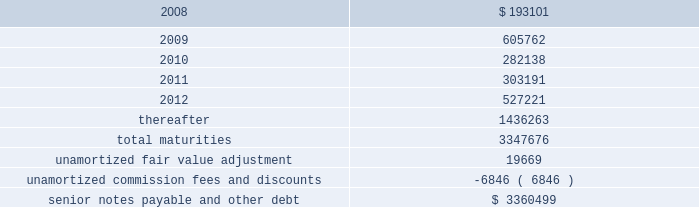Ventas , inc .
Notes to consolidated financial statements 2014 ( continued ) applicable indenture .
The issuers may also redeem the 2015 senior notes , in whole at any time or in part from time to time , on or after june 1 , 2010 at varying redemption prices set forth in the applicable indenture , plus accrued and unpaid interest thereon to the redemption date .
In addition , at any time prior to june 1 , 2008 , the issuers may redeem up to 35% ( 35 % ) of the aggregate principal amount of either or both of the 2010 senior notes and 2015 senior notes with the net cash proceeds from certain equity offerings at redemption prices equal to 106.750% ( 106.750 % ) and 107.125% ( 107.125 % ) , respectively , of the principal amount thereof , plus , in each case , accrued and unpaid interest thereon to the redemption date .
The issuers may redeem the 2014 senior notes , in whole at any time or in part from time to time , ( i ) prior to october 15 , 2009 at a redemption price equal to 100% ( 100 % ) of the principal amount thereof , plus a make-whole premium as described in the applicable indenture and ( ii ) on or after october 15 , 2009 at varying redemption prices set forth in the applicable indenture , plus , in each case , accrued and unpaid interest thereon to the redemption date .
The issuers may redeem the 2009 senior notes and the 2012 senior notes , in whole at any time or in part from time to time , at a redemption price equal to 100% ( 100 % ) of the principal amount thereof , plus accrued and unpaid interest thereon to the redemption date and a make-whole premium as described in the applicable indenture .
If we experience certain kinds of changes of control , the issuers must make an offer to repurchase the senior notes , in whole or in part , at a purchase price in cash equal to 101% ( 101 % ) of the principal amount of the senior notes , plus any accrued and unpaid interest to the date of purchase ; provided , however , that in the event moody 2019s and s&p have confirmed their ratings at ba3 or higher and bb- or higher on the senior notes and certain other conditions are met , this repurchase obligation will not apply .
Mortgages at december 31 , 2007 , we had outstanding 121 mortgage loans totaling $ 1.57 billion that are collateralized by the underlying assets of the properties .
Outstanding principal balances on these loans ranged from $ 0.4 million to $ 59.4 million as of december 31 , 2007 .
The loans generally bear interest at fixed rates ranging from 5.4% ( 5.4 % ) to 8.5% ( 8.5 % ) per annum , except for 15 loans with outstanding principal balances ranging from $ 0.4 million to $ 32.0 million , which bear interest at the lender 2019s variable rates ranging from 3.4% ( 3.4 % ) to 7.3% ( 7.3 % ) per annum as of december 31 , 2007 .
At december 31 , 2007 , the weighted average annual rate on fixed rate debt was 6.5% ( 6.5 % ) and the weighted average annual rate on the variable rate debt was 6.1% ( 6.1 % ) .
The loans had a weighted average maturity of 7.0 years as of december 31 , 2007 .
Sunrise 2019s portion of total debt was $ 157.1 million as of december 31 , scheduled maturities of borrowing arrangements and other provisions as of december 31 , 2007 , our indebtedness had the following maturities ( in thousands ) : .

What percentage of total maturities expire after 2012? 
Computations: (1436263 / 3347676)
Answer: 0.42903. 